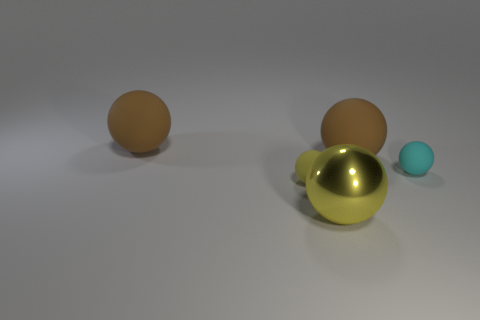Do the large metal object and the small yellow matte thing have the same shape?
Your response must be concise. Yes. Is the size of the metal thing the same as the yellow ball that is behind the yellow metallic sphere?
Keep it short and to the point. No. Is there a tiny block made of the same material as the big yellow sphere?
Your answer should be very brief. No. What number of balls are big rubber objects or cyan things?
Provide a short and direct response. 3. There is a matte object in front of the small cyan matte ball; are there any small yellow spheres on the left side of it?
Make the answer very short. No. Are there fewer yellow shiny spheres than brown spheres?
Give a very brief answer. Yes. What number of brown rubber things are the same shape as the big metallic thing?
Your answer should be very brief. 2. What number of yellow objects are big things or tiny spheres?
Your answer should be compact. 2. There is a matte object that is right of the brown matte object that is on the right side of the tiny yellow matte ball; what is its size?
Give a very brief answer. Small. What material is the other yellow object that is the same shape as the small yellow thing?
Offer a terse response. Metal. 